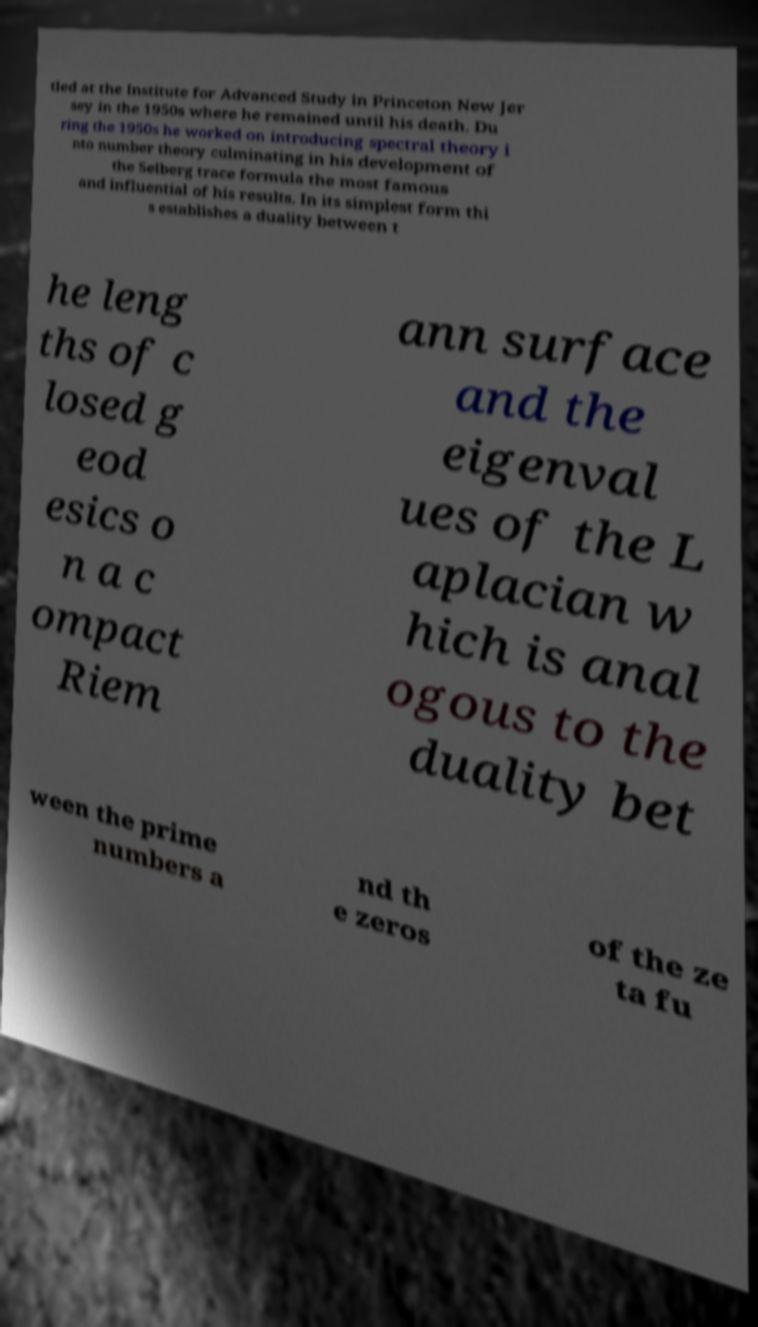For documentation purposes, I need the text within this image transcribed. Could you provide that? tled at the Institute for Advanced Study in Princeton New Jer sey in the 1950s where he remained until his death. Du ring the 1950s he worked on introducing spectral theory i nto number theory culminating in his development of the Selberg trace formula the most famous and influential of his results. In its simplest form thi s establishes a duality between t he leng ths of c losed g eod esics o n a c ompact Riem ann surface and the eigenval ues of the L aplacian w hich is anal ogous to the duality bet ween the prime numbers a nd th e zeros of the ze ta fu 